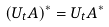Convert formula to latex. <formula><loc_0><loc_0><loc_500><loc_500>( U _ { t } A ) ^ { * } = U _ { t } A ^ { * }</formula> 